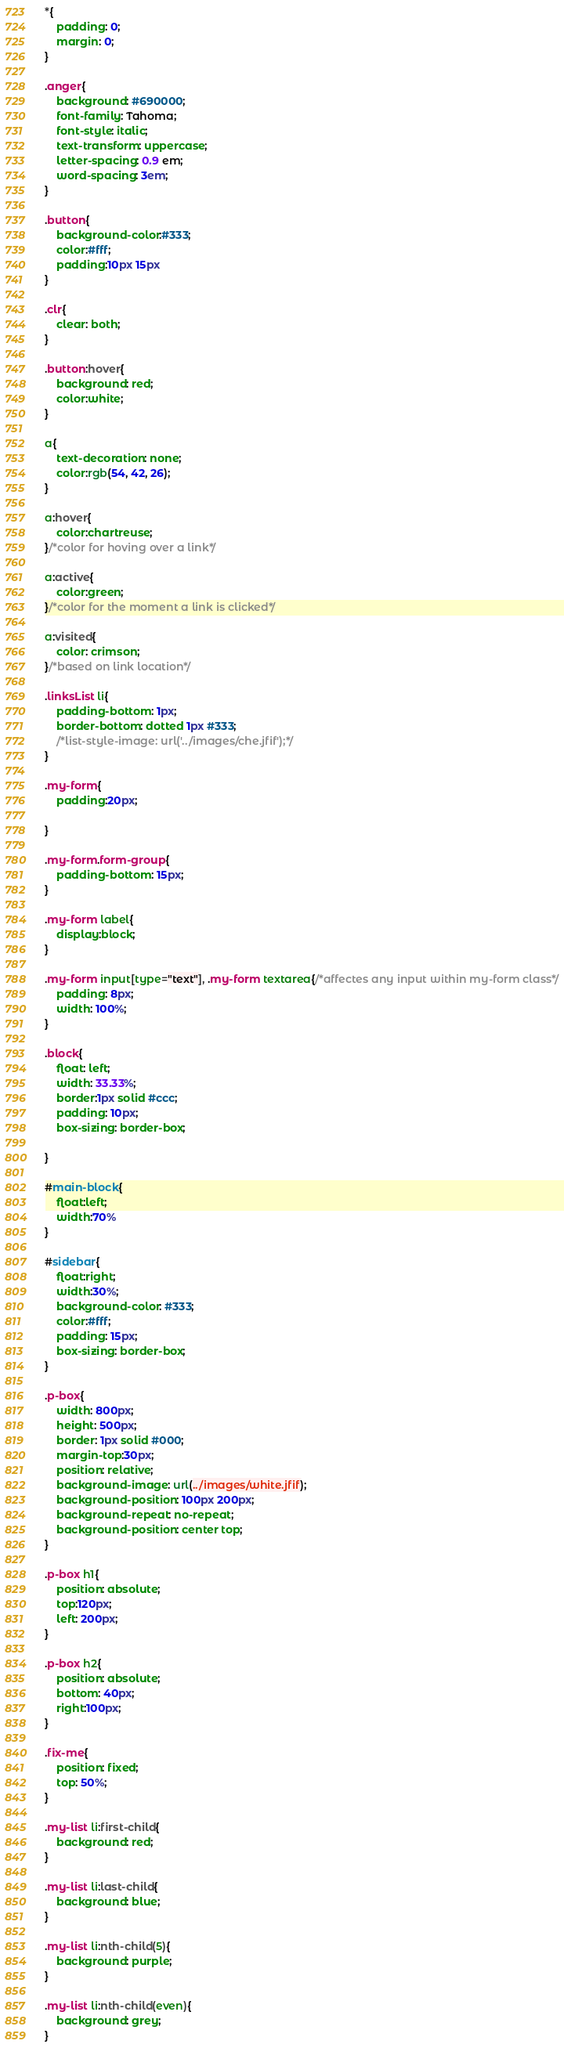<code> <loc_0><loc_0><loc_500><loc_500><_CSS_>*{
    padding: 0;
    margin: 0;
}

.anger{
    background: #690000;
    font-family: Tahoma;
    font-style: italic;
    text-transform: uppercase;
    letter-spacing: 0.9 em;
    word-spacing: 3em;
}

.button{
    background-color:#333;
    color:#fff;
    padding:10px 15px
}

.clr{
    clear: both;
}

.button:hover{
    background: red;
    color:white;
}

a{
    text-decoration: none;
    color:rgb(54, 42, 26);
}

a:hover{
    color:chartreuse;
}/*color for hoving over a link*/

a:active{
    color:green;
}/*color for the moment a link is clicked*/

a:visited{
    color: crimson;
}/*based on link location*/

.linksList li{
    padding-bottom: 1px;
    border-bottom: dotted 1px #333;
    /*list-style-image: url('../images/che.jfif');*/
}

.my-form{
    padding:20px;

}

.my-form.form-group{
    padding-bottom: 15px;
}

.my-form label{
    display:block;
}

.my-form input[type="text"], .my-form textarea{/*affectes any input within my-form class*/
    padding: 8px;
    width: 100%;
}

.block{
    float: left;
    width: 33.33%;
    border:1px solid #ccc;
    padding: 10px;
    box-sizing: border-box;
    
}

#main-block{
    float:left;
    width:70%
}

#sidebar{
    float:right;
    width:30%;
    background-color: #333;
    color:#fff;
    padding: 15px;
    box-sizing: border-box;
}

.p-box{
    width: 800px;
    height: 500px;
    border: 1px solid #000;
    margin-top:30px;
    position: relative;
    background-image: url(../images/white.jfif);
    background-position: 100px 200px;
    background-repeat: no-repeat;
    background-position: center top;
}

.p-box h1{
    position: absolute;
    top:120px;
    left: 200px;
}

.p-box h2{
    position: absolute;
    bottom: 40px;
    right:100px;
}

.fix-me{
    position: fixed;
    top: 50%;
}

.my-list li:first-child{
    background: red;
}

.my-list li:last-child{
    background: blue;
}

.my-list li:nth-child(5){
    background: purple;
}

.my-list li:nth-child(even){
    background: grey;
}</code> 